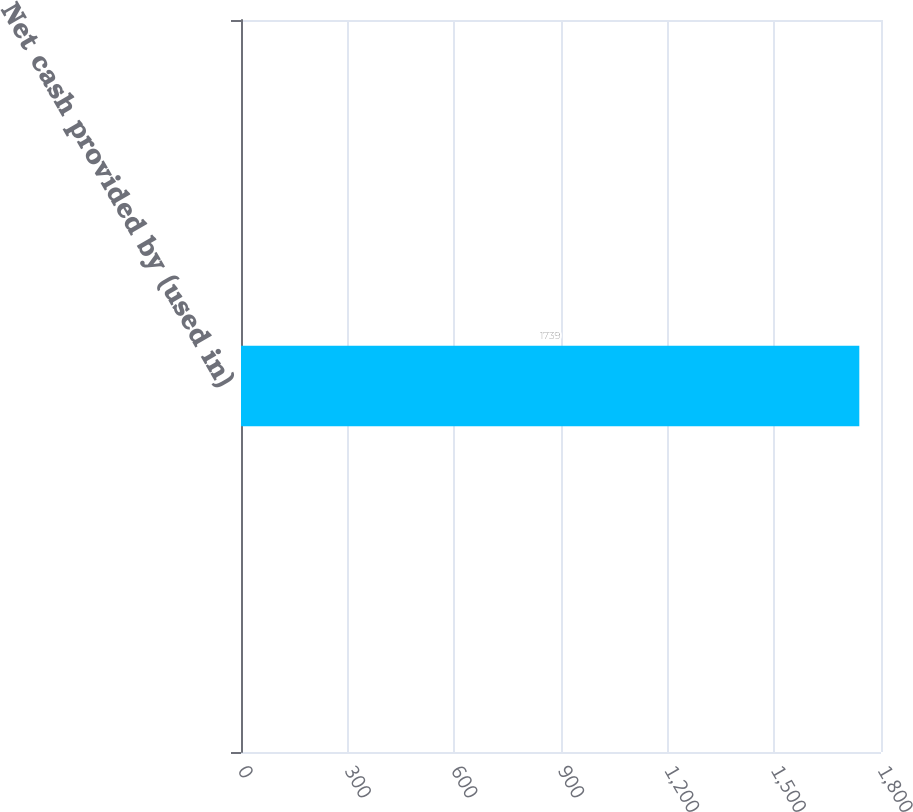Convert chart. <chart><loc_0><loc_0><loc_500><loc_500><bar_chart><fcel>Net cash provided by (used in)<nl><fcel>1739<nl></chart> 